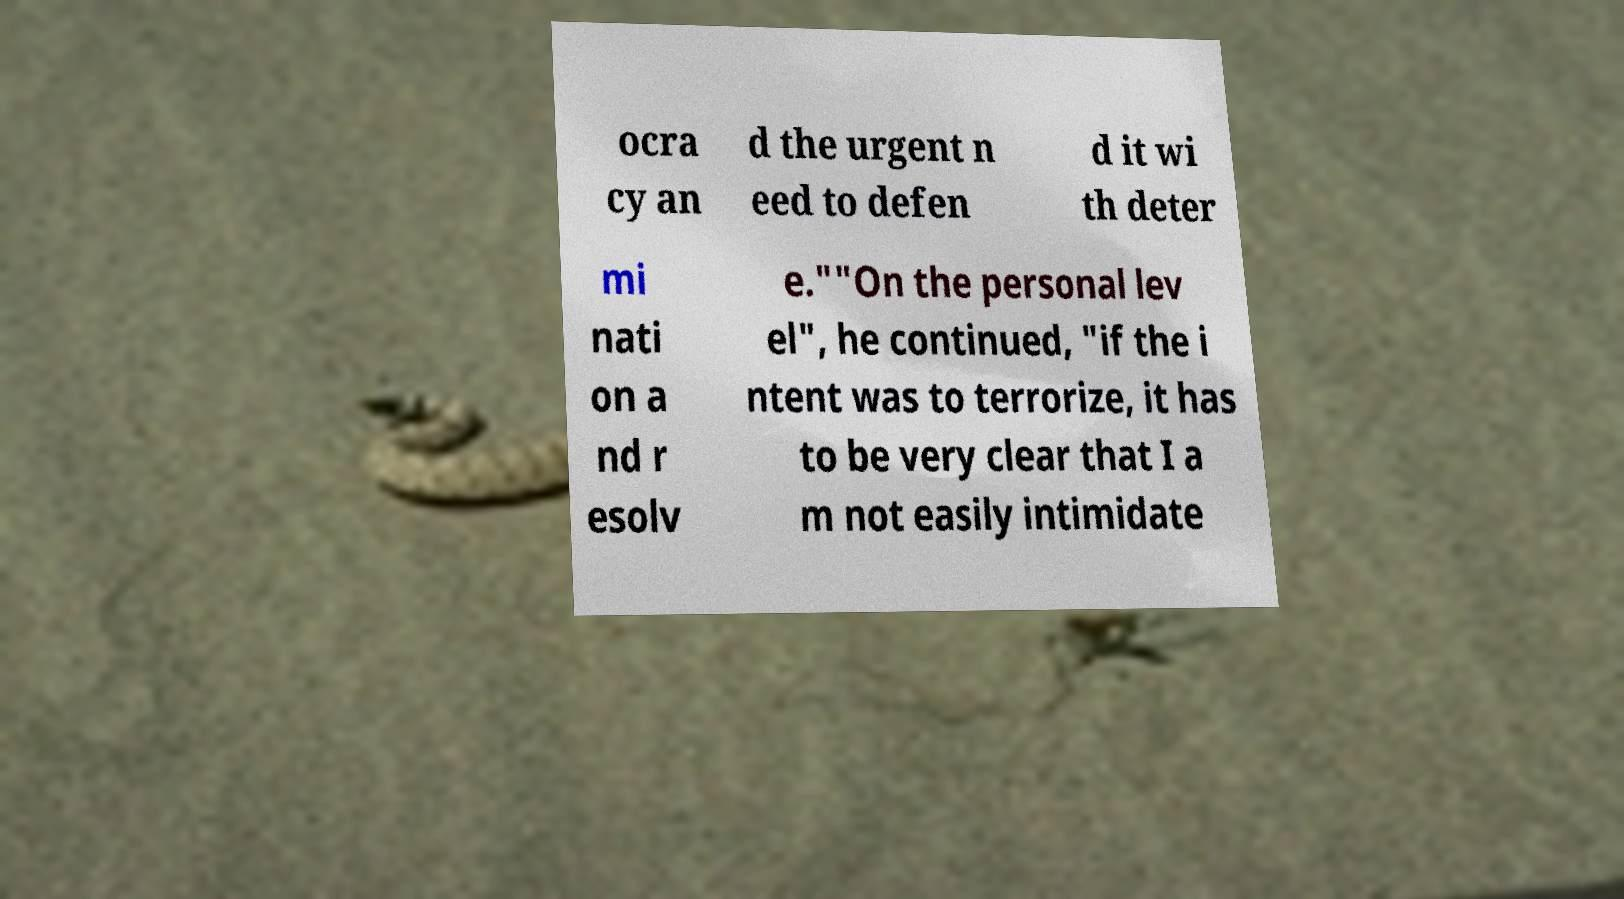For documentation purposes, I need the text within this image transcribed. Could you provide that? ocra cy an d the urgent n eed to defen d it wi th deter mi nati on a nd r esolv e.""On the personal lev el", he continued, "if the i ntent was to terrorize, it has to be very clear that I a m not easily intimidate 